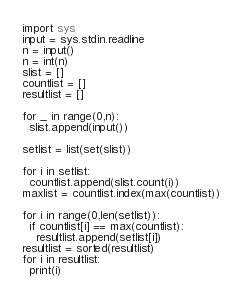<code> <loc_0><loc_0><loc_500><loc_500><_Python_>import sys
input = sys.stdin.readline
n = input()
n = int(n)
slist = []
countlist = []
resultlist = []

for _ in range(0,n):
  slist.append(input())

setlist = list(set(slist))

for i in setlist:
  countlist.append(slist.count(i))
maxlist = countlist.index(max(countlist))

for i in range(0,len(setlist)):
  if countlist[i] == max(countlist):
    resultlist.append(setlist[i])
resultlist = sorted(resultlist)
for i in resultlist:
  print(i)</code> 